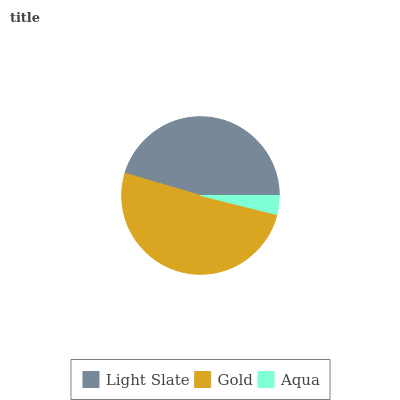Is Aqua the minimum?
Answer yes or no. Yes. Is Gold the maximum?
Answer yes or no. Yes. Is Gold the minimum?
Answer yes or no. No. Is Aqua the maximum?
Answer yes or no. No. Is Gold greater than Aqua?
Answer yes or no. Yes. Is Aqua less than Gold?
Answer yes or no. Yes. Is Aqua greater than Gold?
Answer yes or no. No. Is Gold less than Aqua?
Answer yes or no. No. Is Light Slate the high median?
Answer yes or no. Yes. Is Light Slate the low median?
Answer yes or no. Yes. Is Gold the high median?
Answer yes or no. No. Is Gold the low median?
Answer yes or no. No. 